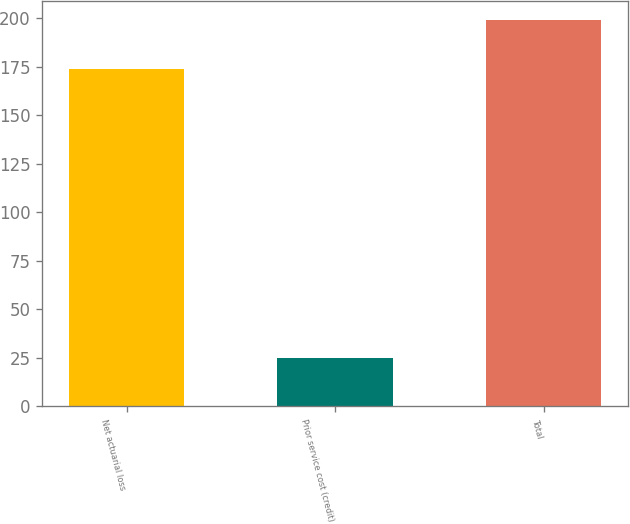Convert chart to OTSL. <chart><loc_0><loc_0><loc_500><loc_500><bar_chart><fcel>Net actuarial loss<fcel>Prior service cost (credit)<fcel>Total<nl><fcel>174<fcel>25<fcel>199<nl></chart> 